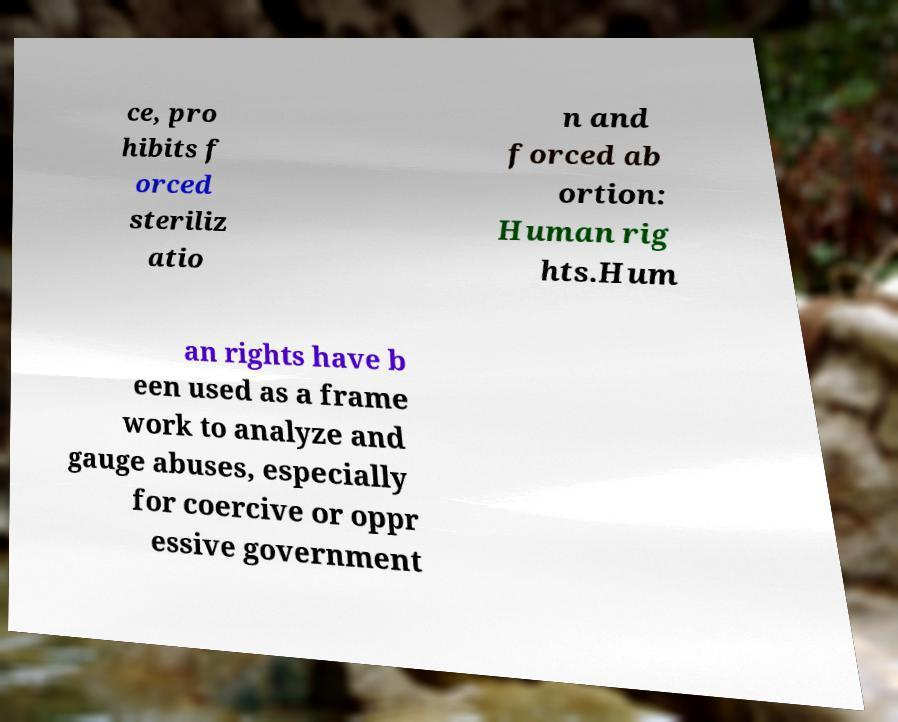Could you extract and type out the text from this image? ce, pro hibits f orced steriliz atio n and forced ab ortion: Human rig hts.Hum an rights have b een used as a frame work to analyze and gauge abuses, especially for coercive or oppr essive government 